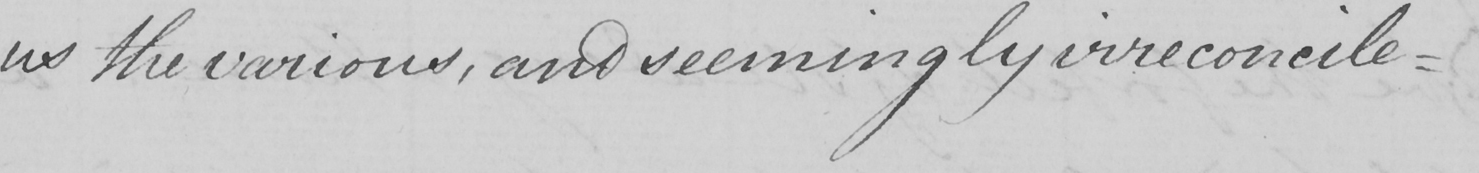What is written in this line of handwriting? us the various , and seemingly irreconcile- 